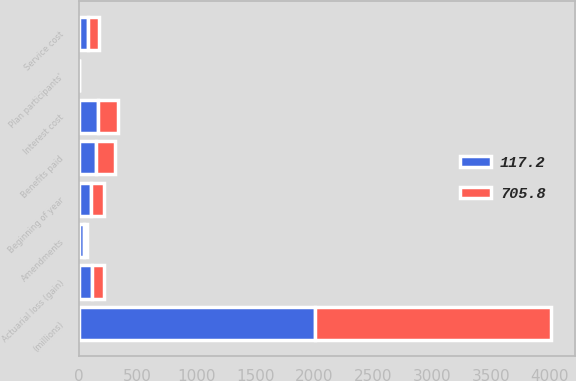<chart> <loc_0><loc_0><loc_500><loc_500><stacked_bar_chart><ecel><fcel>(millions)<fcel>Beginning of year<fcel>Service cost<fcel>Interest cost<fcel>Plan participants'<fcel>Amendments<fcel>Actuarial loss (gain)<fcel>Benefits paid<nl><fcel>705.8<fcel>2006<fcel>105.5<fcel>94.2<fcel>172<fcel>1.7<fcel>24.2<fcel>96.7<fcel>160.4<nl><fcel>117.2<fcel>2005<fcel>105.5<fcel>80.2<fcel>160.1<fcel>2.5<fcel>42.2<fcel>114.3<fcel>144<nl></chart> 